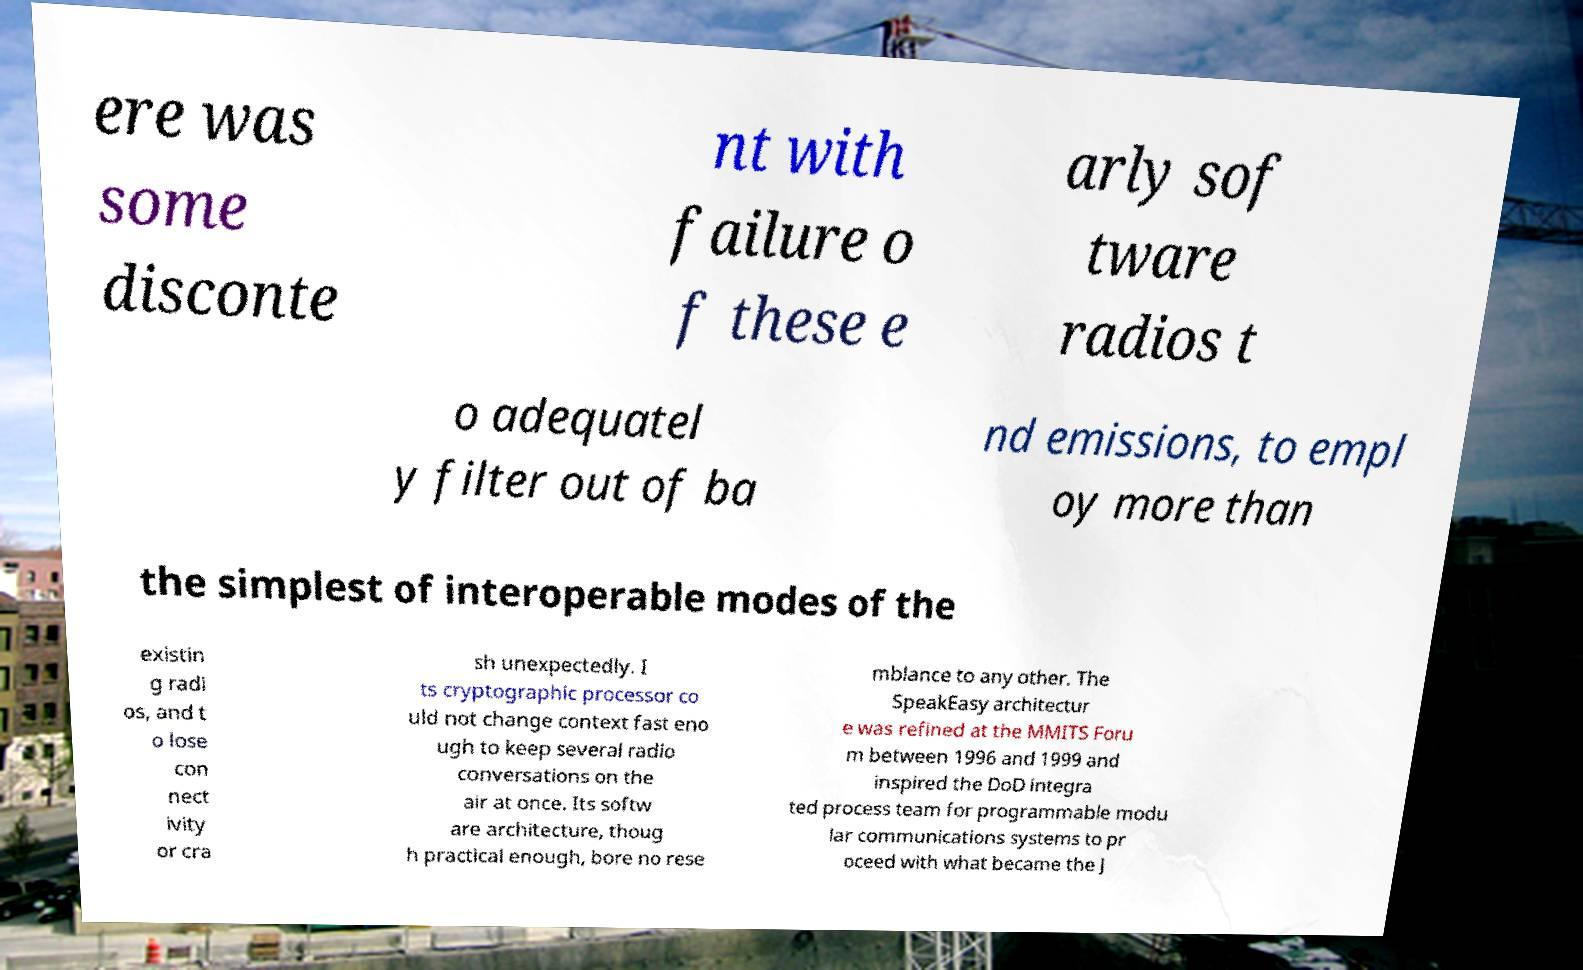Please read and relay the text visible in this image. What does it say? ere was some disconte nt with failure o f these e arly sof tware radios t o adequatel y filter out of ba nd emissions, to empl oy more than the simplest of interoperable modes of the existin g radi os, and t o lose con nect ivity or cra sh unexpectedly. I ts cryptographic processor co uld not change context fast eno ugh to keep several radio conversations on the air at once. Its softw are architecture, thoug h practical enough, bore no rese mblance to any other. The SpeakEasy architectur e was refined at the MMITS Foru m between 1996 and 1999 and inspired the DoD integra ted process team for programmable modu lar communications systems to pr oceed with what became the J 